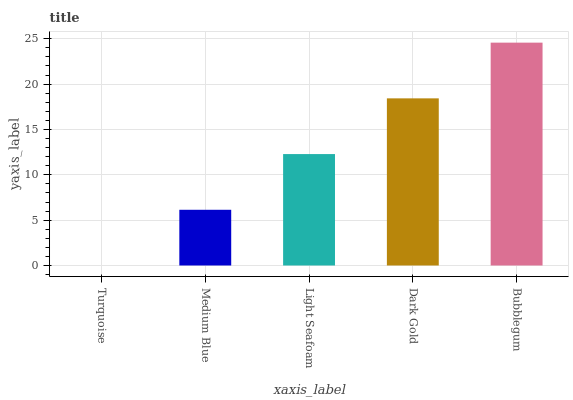Is Turquoise the minimum?
Answer yes or no. Yes. Is Bubblegum the maximum?
Answer yes or no. Yes. Is Medium Blue the minimum?
Answer yes or no. No. Is Medium Blue the maximum?
Answer yes or no. No. Is Medium Blue greater than Turquoise?
Answer yes or no. Yes. Is Turquoise less than Medium Blue?
Answer yes or no. Yes. Is Turquoise greater than Medium Blue?
Answer yes or no. No. Is Medium Blue less than Turquoise?
Answer yes or no. No. Is Light Seafoam the high median?
Answer yes or no. Yes. Is Light Seafoam the low median?
Answer yes or no. Yes. Is Dark Gold the high median?
Answer yes or no. No. Is Medium Blue the low median?
Answer yes or no. No. 